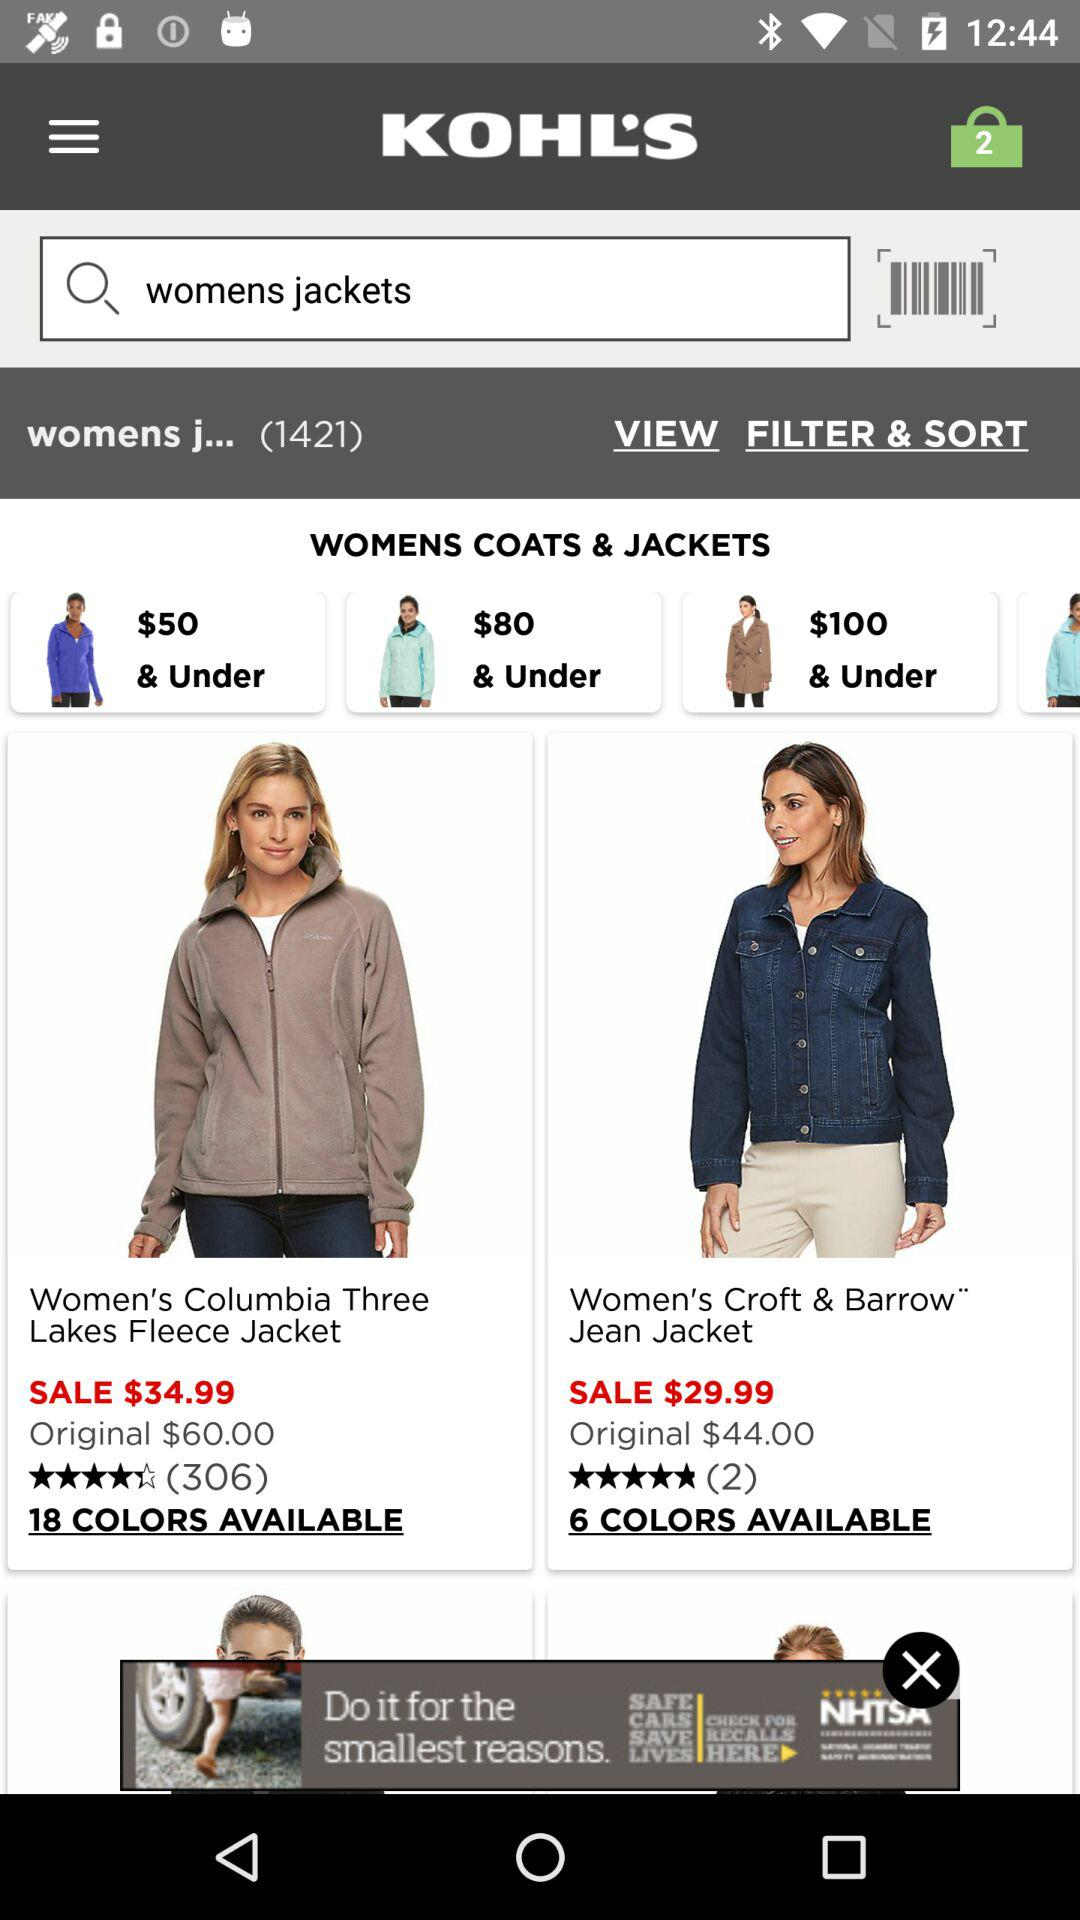How many colors are available in "Women's Croft & Barrow" Jean Jacket"? There are 6 colors available. 